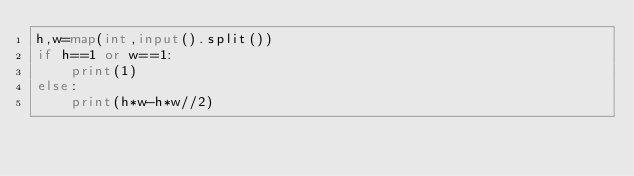<code> <loc_0><loc_0><loc_500><loc_500><_Python_>h,w=map(int,input().split())
if h==1 or w==1:
    print(1)
else:
    print(h*w-h*w//2)</code> 